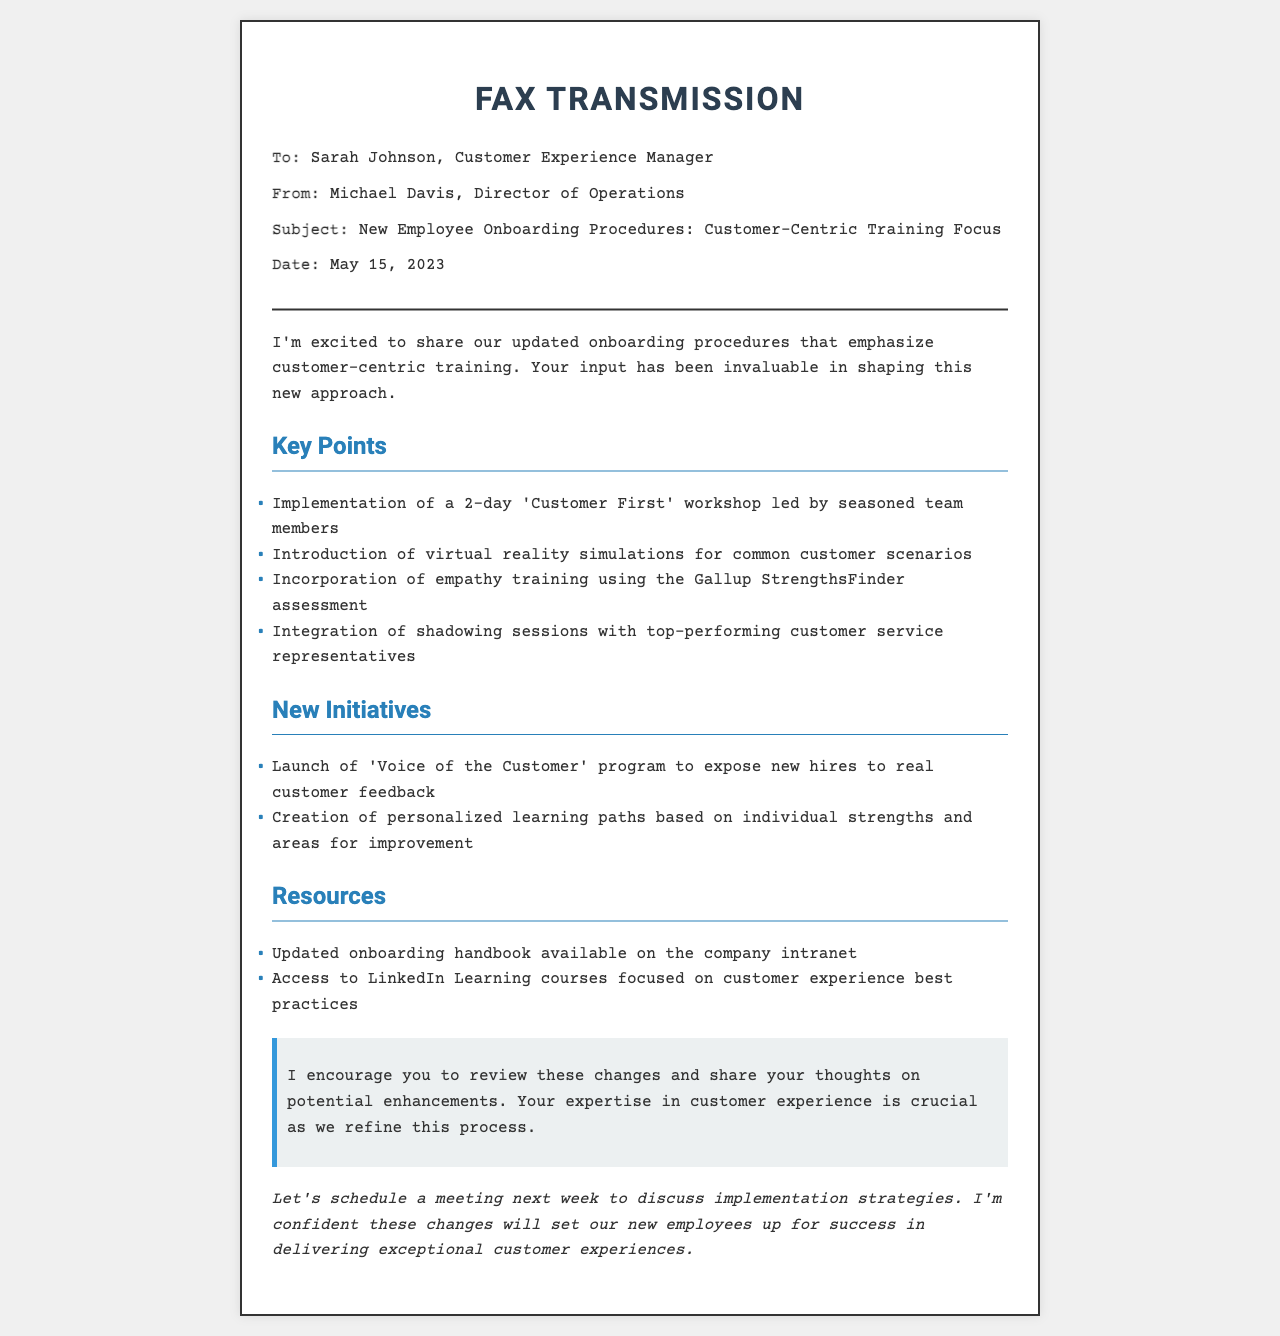What is the subject of the fax? The subject is the main topic being communicated in the fax, which is outlined in the header section.
Answer: New Employee Onboarding Procedures: Customer-Centric Training Focus Who is the fax addressed to? The recipient is specified in the header section of the fax.
Answer: Sarah Johnson What date was the fax sent? The date provides context for when the information was shared, located in the header.
Answer: May 15, 2023 What is one of the key points mentioned? Key points are highlighted under a specific section in the content of the fax.
Answer: Implementation of a 2-day 'Customer First' workshop led by seasoned team members How many new initiatives are listed in the document? This question requires counting the initiatives listed under the relevant section.
Answer: 2 What type of training is incorporated into the onboarding procedures? This information is found in the content section where specific training methods are mentioned.
Answer: Empathy training What program is launched to expose new hires to real customer feedback? The specific program is mentioned in the New Initiatives section.
Answer: Voice of the Customer program Where can new hires find the updated onboarding handbook? The location of the resource is specified in the Resources section.
Answer: Company intranet What is the purpose of scheduling a meeting next week? The intent behind the meeting is outlined, requiring an understanding of the overall aim of the communication.
Answer: Discuss implementation strategies 